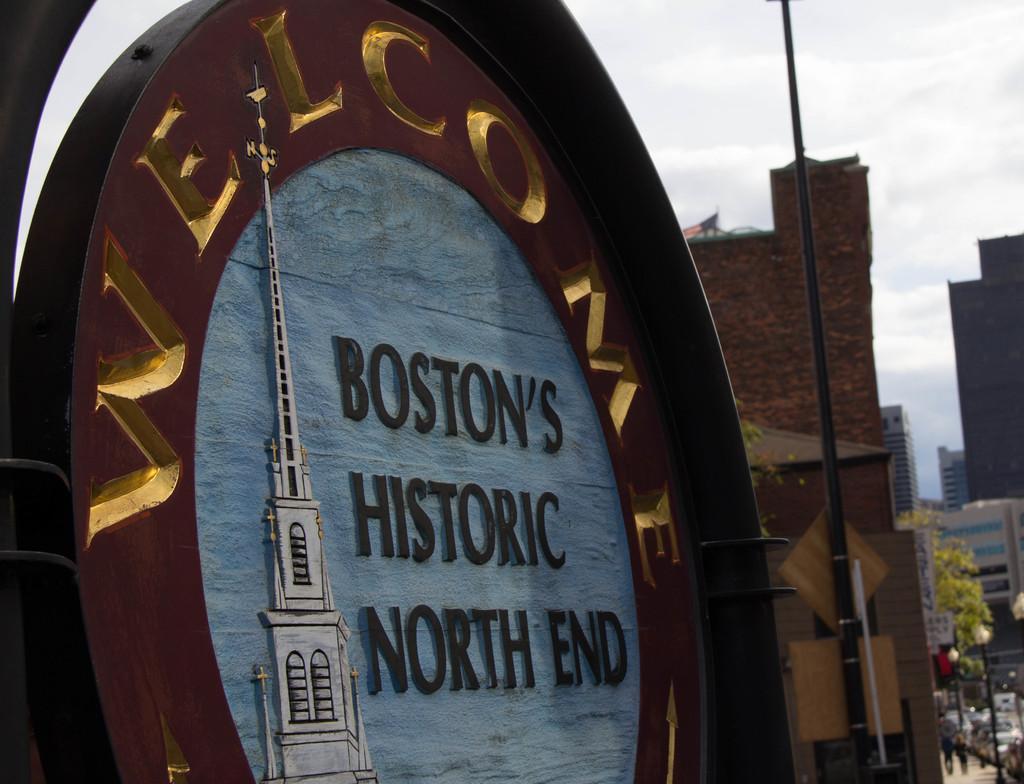Could you give a brief overview of what you see in this image? In this image we can see the name of the street, there we can see a pole, few buildings, few vehicles on the road, two people on the pavement, few trees and the sky. 